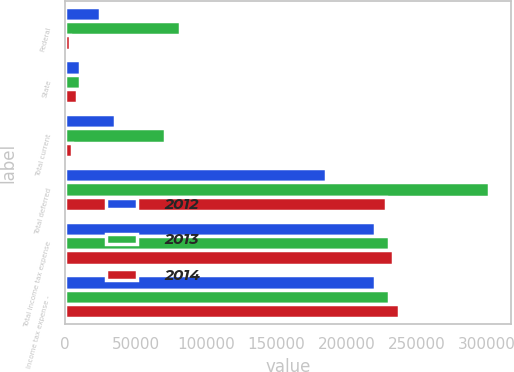<chart> <loc_0><loc_0><loc_500><loc_500><stacked_bar_chart><ecel><fcel>Federal<fcel>State<fcel>Total current<fcel>Total deferred<fcel>Total income tax expense<fcel>Income tax expense -<nl><fcel>2012<fcel>25054<fcel>10382<fcel>35436<fcel>185269<fcel>220705<fcel>220705<nl><fcel>2013<fcel>81784<fcel>10537<fcel>71247<fcel>301838<fcel>230591<fcel>230591<nl><fcel>2014<fcel>3493<fcel>8395<fcel>4902<fcel>228602<fcel>233504<fcel>237317<nl></chart> 